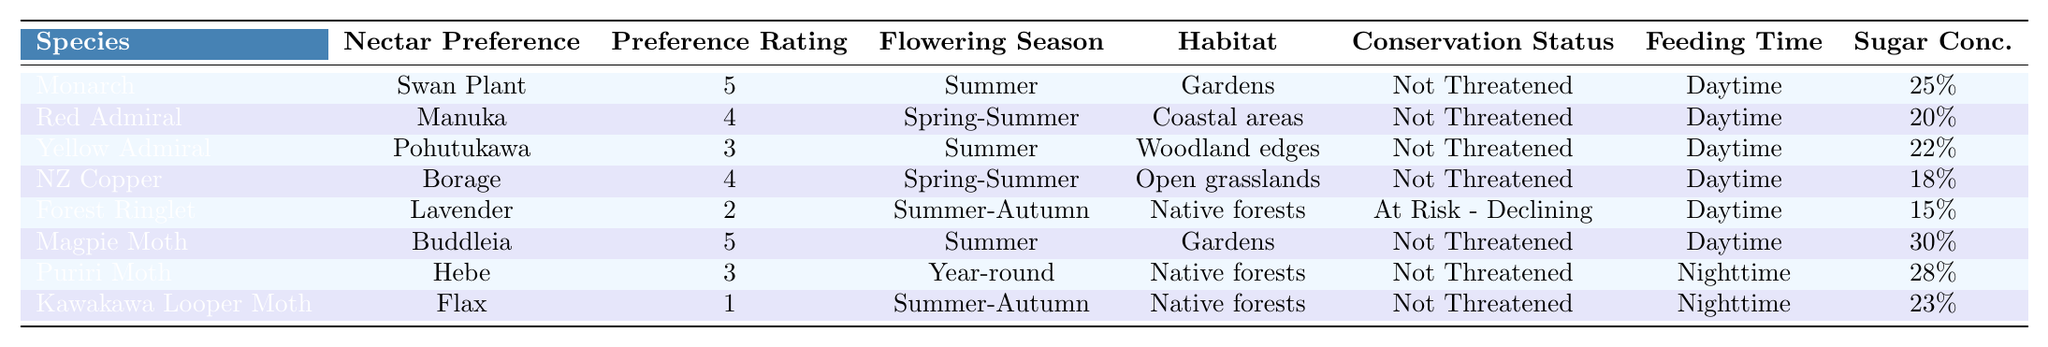What is the nectar preference of the Forest Ringlet? The table shows that the Forest Ringlet has a nectar preference for Lavender.
Answer: Lavender Which species has the highest preference rating? According to the table, the Monarch and Magpie Moth both have a preference rating of 5, which is the highest rating.
Answer: Monarch and Magpie Moth Is the Kawakawa Looper Moth active at night? The table indicates that the Kawakawa Looper Moth has a feeding time labeled as Nighttime, meaning it is indeed active at night.
Answer: Yes What is the average sugar concentration of the nectar preferences? To find the average sugar concentration, we first convert each percentage to a decimal: 0.25, 0.20, 0.22, 0.18, 0.15, 0.30, 0.28, 0.23. Next, we sum these values: 0.25 + 0.20 + 0.22 + 0.18 + 0.15 + 0.30 + 0.28 + 0.23 = 1.81. Then, we divide by 8, as there are 8 entries: 1.81 / 8 = 0.22625, which converts back to a percentage of approximately 22.63%.
Answer: 22.63% How many species are there with a conservation status of "Not Threatened"? From the table, we can count: Monarch, Red Admiral, Yellow Admiral, NZ Copper, Magpie Moth, Puriri Moth. This totals to 6 species.
Answer: 6 Which species has a preference for Flax and what is its preference rating? The table indicates that the Kawakawa Looper Moth prefers Flax, and its preference rating is 1.
Answer: Kawakawa Looper Moth, 1 Which habitat is associated with the highest-rated nectar preference plants? The highest-rated nectar preferences belong to the Monarch (Swan Plant) and Magpie Moth (Buddleia). Both have habitats in Gardens, so the Gardens habitat is associated with the highest-rated nectar preference plants.
Answer: Gardens Are there any species that prefer plants flowering in both summer and autumn? Both the Forest Ringlet and Kawakawa Looper Moth prefer plants that flower during Summer-Autumn according to the table.
Answer: Yes What plant has the lowest preference rating and what is its sugar concentration? The table indicates that the Forest Ringlet has the lowest preference rating of 2 for Lavender, with a sugar concentration of 15%.
Answer: Lavender, 15% 